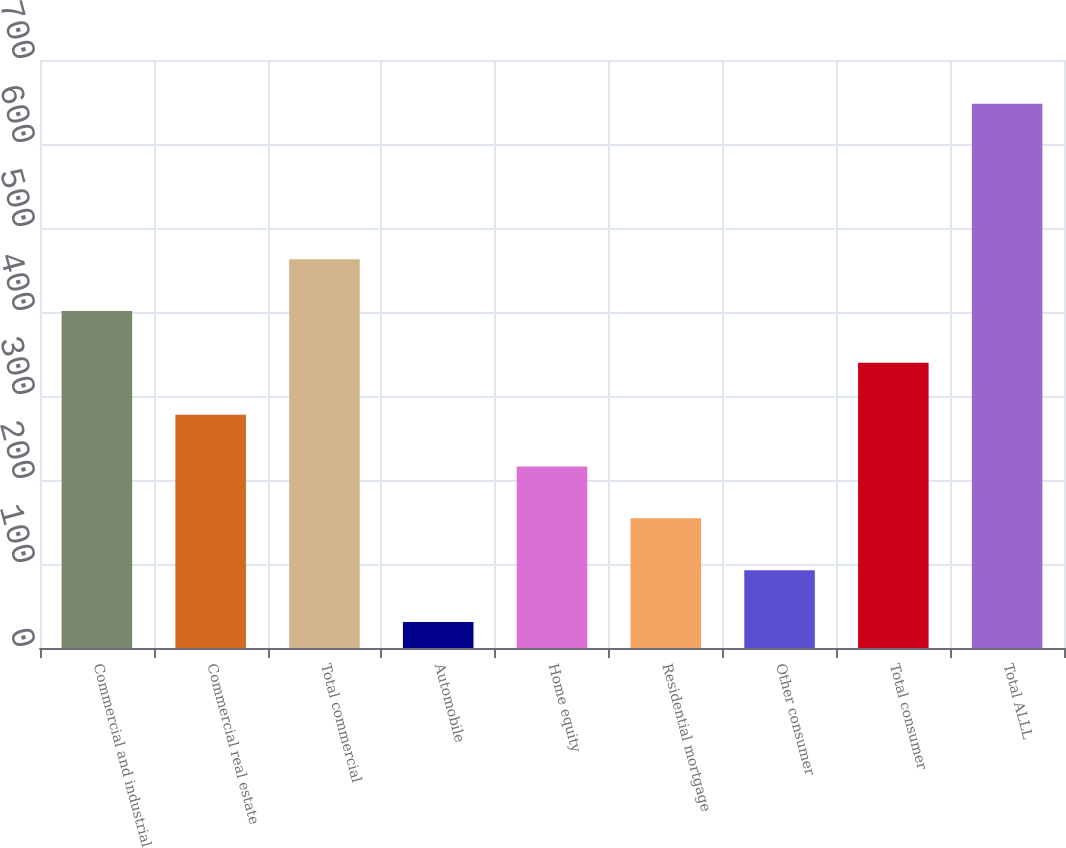Convert chart. <chart><loc_0><loc_0><loc_500><loc_500><bar_chart><fcel>Commercial and industrial<fcel>Commercial real estate<fcel>Total commercial<fcel>Automobile<fcel>Home equity<fcel>Residential mortgage<fcel>Other consumer<fcel>Total consumer<fcel>Total ALLL<nl><fcel>401.2<fcel>277.8<fcel>462.9<fcel>31<fcel>216.1<fcel>154.4<fcel>92.7<fcel>339.5<fcel>648<nl></chart> 